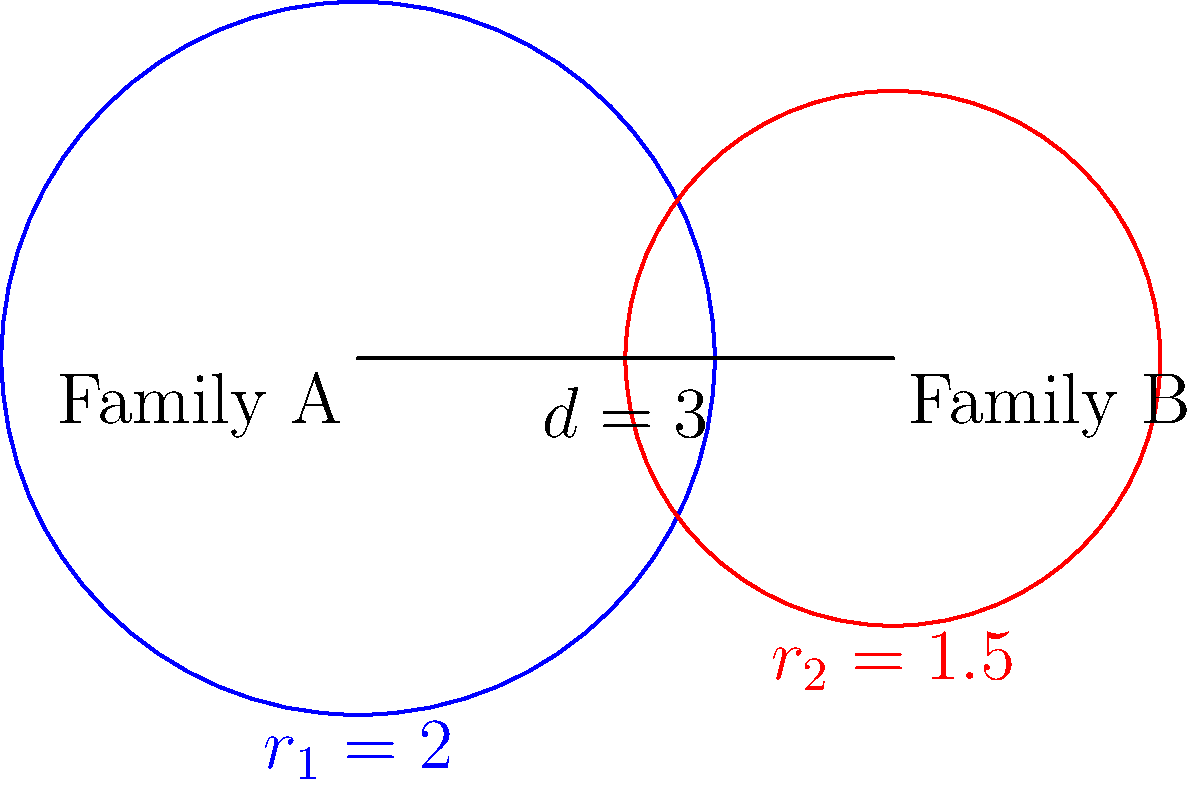In a genealogical study, two family trees are represented by overlapping circles. Family A's tree has a radius of 2 units, while Family B's tree has a radius of 1.5 units. The centers of these circles are 3 units apart. Calculate the area of the overlapping region between these two family trees, representing shared ancestors. Round your answer to two decimal places. To find the area of the overlapping region, we'll use the formula for the area of intersection of two circles:

1) First, calculate the distance $a$ from the center of each circle to the chord of intersection:
   $$a_1 = \frac{r_1^2 - r_2^2 + d^2}{2d} \text{ and } a_2 = d - a_1$$
   Where $r_1 = 2$, $r_2 = 1.5$, and $d = 3$

2) Calculate $a_1$:
   $$a_1 = \frac{2^2 - 1.5^2 + 3^2}{2(3)} = \frac{4 - 2.25 + 9}{6} = 1.79167$$

3) Calculate $a_2$:
   $$a_2 = 3 - 1.79167 = 1.20833$$

4) Find the central angle $\theta$ for each circle:
   $$\theta_1 = 2 \arccos(\frac{a_1}{r_1}) \text{ and } \theta_2 = 2 \arccos(\frac{a_2}{r_2})$$

5) Calculate $\theta_1$ and $\theta_2$:
   $$\theta_1 = 2 \arccos(\frac{1.79167}{2}) = 1.15995 \text{ radians}$$
   $$\theta_2 = 2 \arccos(\frac{1.20833}{1.5}) = 1.74622 \text{ radians}$$

6) The area of intersection is:
   $$A = r_1^2 (\frac{\theta_1}{2} - \frac{\sin \theta_1}{2}) + r_2^2 (\frac{\theta_2}{2} - \frac{\sin \theta_2}{2})$$

7) Substitute the values:
   $$A = 2^2 (\frac{1.15995}{2} - \frac{\sin 1.15995}{2}) + 1.5^2 (\frac{1.74622}{2} - \frac{\sin 1.74622}{2})$$

8) Calculate:
   $$A = 4(0.57998 - 0.46061) + 2.25(0.87311 - 0.72054) = 0.47748 + 0.34330 = 0.82078$$

9) Round to two decimal places: 0.82
Answer: 0.82 square units 